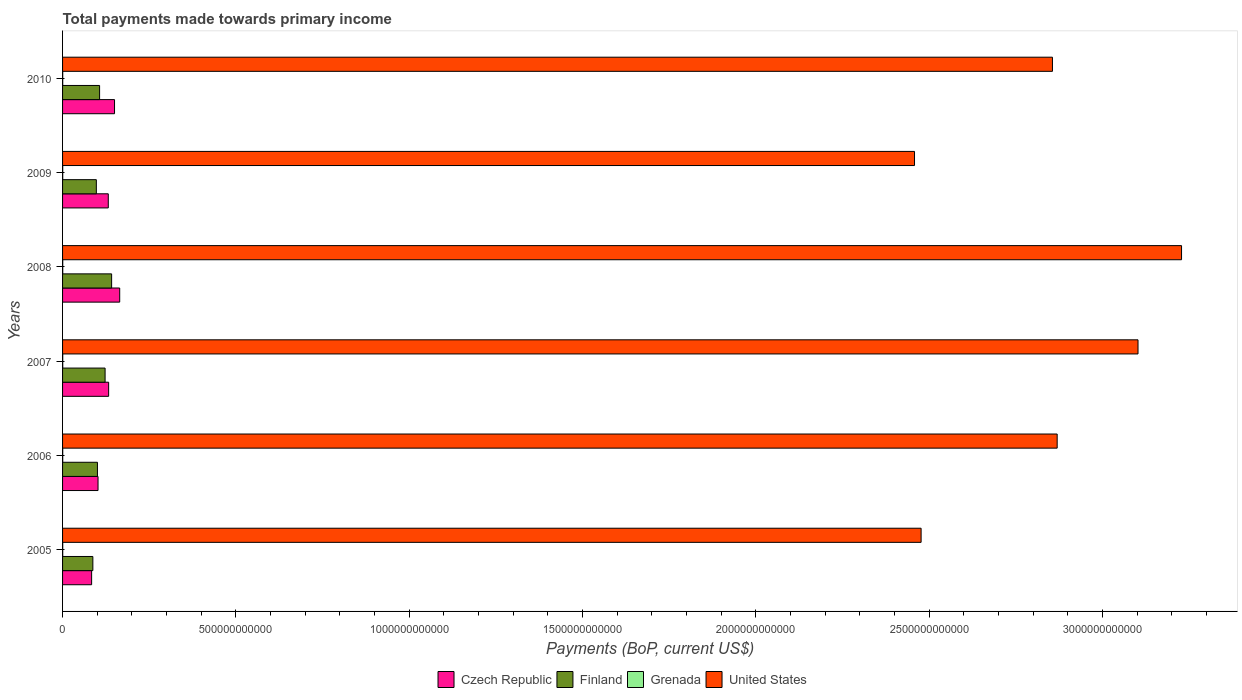How many different coloured bars are there?
Provide a short and direct response. 4. How many groups of bars are there?
Provide a succinct answer. 6. Are the number of bars on each tick of the Y-axis equal?
Your response must be concise. Yes. How many bars are there on the 2nd tick from the bottom?
Provide a short and direct response. 4. In how many cases, is the number of bars for a given year not equal to the number of legend labels?
Offer a very short reply. 0. What is the total payments made towards primary income in United States in 2009?
Give a very brief answer. 2.46e+12. Across all years, what is the maximum total payments made towards primary income in Grenada?
Offer a very short reply. 5.03e+08. Across all years, what is the minimum total payments made towards primary income in United States?
Ensure brevity in your answer.  2.46e+12. What is the total total payments made towards primary income in Czech Republic in the graph?
Your answer should be compact. 7.66e+11. What is the difference between the total payments made towards primary income in Finland in 2007 and that in 2010?
Your response must be concise. 1.58e+1. What is the difference between the total payments made towards primary income in Finland in 2006 and the total payments made towards primary income in Grenada in 2005?
Keep it short and to the point. 1.00e+11. What is the average total payments made towards primary income in United States per year?
Give a very brief answer. 2.83e+12. In the year 2007, what is the difference between the total payments made towards primary income in Finland and total payments made towards primary income in Czech Republic?
Ensure brevity in your answer.  -1.02e+1. What is the ratio of the total payments made towards primary income in Czech Republic in 2009 to that in 2010?
Provide a succinct answer. 0.88. Is the total payments made towards primary income in United States in 2006 less than that in 2007?
Keep it short and to the point. Yes. What is the difference between the highest and the second highest total payments made towards primary income in Finland?
Offer a terse response. 1.89e+1. What is the difference between the highest and the lowest total payments made towards primary income in Grenada?
Your response must be concise. 7.59e+07. In how many years, is the total payments made towards primary income in Czech Republic greater than the average total payments made towards primary income in Czech Republic taken over all years?
Provide a short and direct response. 4. Is it the case that in every year, the sum of the total payments made towards primary income in Czech Republic and total payments made towards primary income in Finland is greater than the sum of total payments made towards primary income in Grenada and total payments made towards primary income in United States?
Offer a very short reply. No. What does the 2nd bar from the top in 2009 represents?
Your response must be concise. Grenada. What does the 4th bar from the bottom in 2008 represents?
Offer a very short reply. United States. Are all the bars in the graph horizontal?
Ensure brevity in your answer.  Yes. How many years are there in the graph?
Give a very brief answer. 6. What is the difference between two consecutive major ticks on the X-axis?
Your response must be concise. 5.00e+11. Are the values on the major ticks of X-axis written in scientific E-notation?
Keep it short and to the point. No. Does the graph contain grids?
Keep it short and to the point. No. How many legend labels are there?
Keep it short and to the point. 4. How are the legend labels stacked?
Provide a succinct answer. Horizontal. What is the title of the graph?
Give a very brief answer. Total payments made towards primary income. What is the label or title of the X-axis?
Provide a short and direct response. Payments (BoP, current US$). What is the label or title of the Y-axis?
Provide a short and direct response. Years. What is the Payments (BoP, current US$) of Czech Republic in 2005?
Your answer should be very brief. 8.38e+1. What is the Payments (BoP, current US$) in Finland in 2005?
Provide a short and direct response. 8.74e+1. What is the Payments (BoP, current US$) in Grenada in 2005?
Make the answer very short. 4.36e+08. What is the Payments (BoP, current US$) of United States in 2005?
Keep it short and to the point. 2.48e+12. What is the Payments (BoP, current US$) in Czech Republic in 2006?
Provide a short and direct response. 1.02e+11. What is the Payments (BoP, current US$) in Finland in 2006?
Offer a terse response. 1.01e+11. What is the Payments (BoP, current US$) of Grenada in 2006?
Offer a very short reply. 4.45e+08. What is the Payments (BoP, current US$) of United States in 2006?
Provide a short and direct response. 2.87e+12. What is the Payments (BoP, current US$) in Czech Republic in 2007?
Your response must be concise. 1.33e+11. What is the Payments (BoP, current US$) in Finland in 2007?
Give a very brief answer. 1.23e+11. What is the Payments (BoP, current US$) in Grenada in 2007?
Make the answer very short. 4.91e+08. What is the Payments (BoP, current US$) in United States in 2007?
Give a very brief answer. 3.10e+12. What is the Payments (BoP, current US$) of Czech Republic in 2008?
Make the answer very short. 1.65e+11. What is the Payments (BoP, current US$) in Finland in 2008?
Offer a very short reply. 1.42e+11. What is the Payments (BoP, current US$) of Grenada in 2008?
Your answer should be compact. 5.03e+08. What is the Payments (BoP, current US$) of United States in 2008?
Give a very brief answer. 3.23e+12. What is the Payments (BoP, current US$) in Czech Republic in 2009?
Give a very brief answer. 1.32e+11. What is the Payments (BoP, current US$) of Finland in 2009?
Provide a succinct answer. 9.74e+1. What is the Payments (BoP, current US$) of Grenada in 2009?
Ensure brevity in your answer.  4.32e+08. What is the Payments (BoP, current US$) in United States in 2009?
Offer a terse response. 2.46e+12. What is the Payments (BoP, current US$) of Czech Republic in 2010?
Keep it short and to the point. 1.50e+11. What is the Payments (BoP, current US$) in Finland in 2010?
Your response must be concise. 1.07e+11. What is the Payments (BoP, current US$) in Grenada in 2010?
Your answer should be compact. 4.27e+08. What is the Payments (BoP, current US$) of United States in 2010?
Offer a terse response. 2.86e+12. Across all years, what is the maximum Payments (BoP, current US$) in Czech Republic?
Offer a very short reply. 1.65e+11. Across all years, what is the maximum Payments (BoP, current US$) of Finland?
Your answer should be compact. 1.42e+11. Across all years, what is the maximum Payments (BoP, current US$) in Grenada?
Your response must be concise. 5.03e+08. Across all years, what is the maximum Payments (BoP, current US$) of United States?
Make the answer very short. 3.23e+12. Across all years, what is the minimum Payments (BoP, current US$) in Czech Republic?
Your answer should be compact. 8.38e+1. Across all years, what is the minimum Payments (BoP, current US$) in Finland?
Provide a succinct answer. 8.74e+1. Across all years, what is the minimum Payments (BoP, current US$) in Grenada?
Your response must be concise. 4.27e+08. Across all years, what is the minimum Payments (BoP, current US$) of United States?
Offer a very short reply. 2.46e+12. What is the total Payments (BoP, current US$) of Czech Republic in the graph?
Your response must be concise. 7.66e+11. What is the total Payments (BoP, current US$) of Finland in the graph?
Provide a short and direct response. 6.56e+11. What is the total Payments (BoP, current US$) of Grenada in the graph?
Offer a very short reply. 2.73e+09. What is the total Payments (BoP, current US$) of United States in the graph?
Make the answer very short. 1.70e+13. What is the difference between the Payments (BoP, current US$) of Czech Republic in 2005 and that in 2006?
Ensure brevity in your answer.  -1.85e+1. What is the difference between the Payments (BoP, current US$) of Finland in 2005 and that in 2006?
Provide a short and direct response. -1.32e+1. What is the difference between the Payments (BoP, current US$) in Grenada in 2005 and that in 2006?
Your response must be concise. -8.66e+06. What is the difference between the Payments (BoP, current US$) of United States in 2005 and that in 2006?
Give a very brief answer. -3.92e+11. What is the difference between the Payments (BoP, current US$) of Czech Republic in 2005 and that in 2007?
Provide a succinct answer. -4.91e+1. What is the difference between the Payments (BoP, current US$) of Finland in 2005 and that in 2007?
Provide a short and direct response. -3.53e+1. What is the difference between the Payments (BoP, current US$) of Grenada in 2005 and that in 2007?
Make the answer very short. -5.53e+07. What is the difference between the Payments (BoP, current US$) in United States in 2005 and that in 2007?
Provide a short and direct response. -6.26e+11. What is the difference between the Payments (BoP, current US$) in Czech Republic in 2005 and that in 2008?
Your response must be concise. -8.10e+1. What is the difference between the Payments (BoP, current US$) of Finland in 2005 and that in 2008?
Your response must be concise. -5.41e+1. What is the difference between the Payments (BoP, current US$) of Grenada in 2005 and that in 2008?
Your response must be concise. -6.67e+07. What is the difference between the Payments (BoP, current US$) of United States in 2005 and that in 2008?
Your response must be concise. -7.51e+11. What is the difference between the Payments (BoP, current US$) in Czech Republic in 2005 and that in 2009?
Your answer should be compact. -4.81e+1. What is the difference between the Payments (BoP, current US$) of Finland in 2005 and that in 2009?
Your response must be concise. -1.01e+1. What is the difference between the Payments (BoP, current US$) in Grenada in 2005 and that in 2009?
Keep it short and to the point. 3.73e+06. What is the difference between the Payments (BoP, current US$) of United States in 2005 and that in 2009?
Offer a very short reply. 1.90e+1. What is the difference between the Payments (BoP, current US$) of Czech Republic in 2005 and that in 2010?
Give a very brief answer. -6.61e+1. What is the difference between the Payments (BoP, current US$) of Finland in 2005 and that in 2010?
Your response must be concise. -1.94e+1. What is the difference between the Payments (BoP, current US$) of Grenada in 2005 and that in 2010?
Offer a terse response. 9.28e+06. What is the difference between the Payments (BoP, current US$) of United States in 2005 and that in 2010?
Provide a succinct answer. -3.79e+11. What is the difference between the Payments (BoP, current US$) in Czech Republic in 2006 and that in 2007?
Give a very brief answer. -3.06e+1. What is the difference between the Payments (BoP, current US$) of Finland in 2006 and that in 2007?
Ensure brevity in your answer.  -2.20e+1. What is the difference between the Payments (BoP, current US$) in Grenada in 2006 and that in 2007?
Keep it short and to the point. -4.66e+07. What is the difference between the Payments (BoP, current US$) in United States in 2006 and that in 2007?
Your answer should be very brief. -2.33e+11. What is the difference between the Payments (BoP, current US$) of Czech Republic in 2006 and that in 2008?
Your answer should be compact. -6.25e+1. What is the difference between the Payments (BoP, current US$) of Finland in 2006 and that in 2008?
Offer a very short reply. -4.09e+1. What is the difference between the Payments (BoP, current US$) of Grenada in 2006 and that in 2008?
Give a very brief answer. -5.80e+07. What is the difference between the Payments (BoP, current US$) in United States in 2006 and that in 2008?
Your answer should be compact. -3.59e+11. What is the difference between the Payments (BoP, current US$) of Czech Republic in 2006 and that in 2009?
Your response must be concise. -2.96e+1. What is the difference between the Payments (BoP, current US$) in Finland in 2006 and that in 2009?
Your answer should be very brief. 3.19e+09. What is the difference between the Payments (BoP, current US$) in Grenada in 2006 and that in 2009?
Give a very brief answer. 1.24e+07. What is the difference between the Payments (BoP, current US$) of United States in 2006 and that in 2009?
Provide a succinct answer. 4.11e+11. What is the difference between the Payments (BoP, current US$) of Czech Republic in 2006 and that in 2010?
Offer a very short reply. -4.76e+1. What is the difference between the Payments (BoP, current US$) of Finland in 2006 and that in 2010?
Make the answer very short. -6.19e+09. What is the difference between the Payments (BoP, current US$) in Grenada in 2006 and that in 2010?
Provide a succinct answer. 1.79e+07. What is the difference between the Payments (BoP, current US$) in United States in 2006 and that in 2010?
Your response must be concise. 1.36e+1. What is the difference between the Payments (BoP, current US$) in Czech Republic in 2007 and that in 2008?
Provide a succinct answer. -3.19e+1. What is the difference between the Payments (BoP, current US$) in Finland in 2007 and that in 2008?
Provide a short and direct response. -1.89e+1. What is the difference between the Payments (BoP, current US$) in Grenada in 2007 and that in 2008?
Your response must be concise. -1.14e+07. What is the difference between the Payments (BoP, current US$) in United States in 2007 and that in 2008?
Provide a succinct answer. -1.26e+11. What is the difference between the Payments (BoP, current US$) of Czech Republic in 2007 and that in 2009?
Your response must be concise. 1.03e+09. What is the difference between the Payments (BoP, current US$) of Finland in 2007 and that in 2009?
Your answer should be very brief. 2.52e+1. What is the difference between the Payments (BoP, current US$) in Grenada in 2007 and that in 2009?
Your response must be concise. 5.90e+07. What is the difference between the Payments (BoP, current US$) of United States in 2007 and that in 2009?
Offer a very short reply. 6.45e+11. What is the difference between the Payments (BoP, current US$) in Czech Republic in 2007 and that in 2010?
Your response must be concise. -1.70e+1. What is the difference between the Payments (BoP, current US$) in Finland in 2007 and that in 2010?
Ensure brevity in your answer.  1.58e+1. What is the difference between the Payments (BoP, current US$) of Grenada in 2007 and that in 2010?
Offer a very short reply. 6.45e+07. What is the difference between the Payments (BoP, current US$) of United States in 2007 and that in 2010?
Offer a very short reply. 2.47e+11. What is the difference between the Payments (BoP, current US$) of Czech Republic in 2008 and that in 2009?
Keep it short and to the point. 3.29e+1. What is the difference between the Payments (BoP, current US$) in Finland in 2008 and that in 2009?
Make the answer very short. 4.41e+1. What is the difference between the Payments (BoP, current US$) of Grenada in 2008 and that in 2009?
Keep it short and to the point. 7.04e+07. What is the difference between the Payments (BoP, current US$) of United States in 2008 and that in 2009?
Your answer should be very brief. 7.70e+11. What is the difference between the Payments (BoP, current US$) of Czech Republic in 2008 and that in 2010?
Provide a succinct answer. 1.49e+1. What is the difference between the Payments (BoP, current US$) of Finland in 2008 and that in 2010?
Make the answer very short. 3.47e+1. What is the difference between the Payments (BoP, current US$) of Grenada in 2008 and that in 2010?
Provide a succinct answer. 7.59e+07. What is the difference between the Payments (BoP, current US$) of United States in 2008 and that in 2010?
Offer a very short reply. 3.72e+11. What is the difference between the Payments (BoP, current US$) in Czech Republic in 2009 and that in 2010?
Give a very brief answer. -1.80e+1. What is the difference between the Payments (BoP, current US$) in Finland in 2009 and that in 2010?
Your response must be concise. -9.38e+09. What is the difference between the Payments (BoP, current US$) in Grenada in 2009 and that in 2010?
Offer a very short reply. 5.55e+06. What is the difference between the Payments (BoP, current US$) of United States in 2009 and that in 2010?
Your answer should be compact. -3.98e+11. What is the difference between the Payments (BoP, current US$) of Czech Republic in 2005 and the Payments (BoP, current US$) of Finland in 2006?
Offer a very short reply. -1.68e+1. What is the difference between the Payments (BoP, current US$) of Czech Republic in 2005 and the Payments (BoP, current US$) of Grenada in 2006?
Give a very brief answer. 8.34e+1. What is the difference between the Payments (BoP, current US$) in Czech Republic in 2005 and the Payments (BoP, current US$) in United States in 2006?
Make the answer very short. -2.79e+12. What is the difference between the Payments (BoP, current US$) in Finland in 2005 and the Payments (BoP, current US$) in Grenada in 2006?
Keep it short and to the point. 8.69e+1. What is the difference between the Payments (BoP, current US$) of Finland in 2005 and the Payments (BoP, current US$) of United States in 2006?
Offer a very short reply. -2.78e+12. What is the difference between the Payments (BoP, current US$) in Grenada in 2005 and the Payments (BoP, current US$) in United States in 2006?
Offer a terse response. -2.87e+12. What is the difference between the Payments (BoP, current US$) of Czech Republic in 2005 and the Payments (BoP, current US$) of Finland in 2007?
Give a very brief answer. -3.89e+1. What is the difference between the Payments (BoP, current US$) in Czech Republic in 2005 and the Payments (BoP, current US$) in Grenada in 2007?
Offer a very short reply. 8.33e+1. What is the difference between the Payments (BoP, current US$) in Czech Republic in 2005 and the Payments (BoP, current US$) in United States in 2007?
Offer a terse response. -3.02e+12. What is the difference between the Payments (BoP, current US$) in Finland in 2005 and the Payments (BoP, current US$) in Grenada in 2007?
Ensure brevity in your answer.  8.69e+1. What is the difference between the Payments (BoP, current US$) in Finland in 2005 and the Payments (BoP, current US$) in United States in 2007?
Your answer should be compact. -3.01e+12. What is the difference between the Payments (BoP, current US$) of Grenada in 2005 and the Payments (BoP, current US$) of United States in 2007?
Make the answer very short. -3.10e+12. What is the difference between the Payments (BoP, current US$) in Czech Republic in 2005 and the Payments (BoP, current US$) in Finland in 2008?
Your answer should be compact. -5.77e+1. What is the difference between the Payments (BoP, current US$) in Czech Republic in 2005 and the Payments (BoP, current US$) in Grenada in 2008?
Provide a short and direct response. 8.33e+1. What is the difference between the Payments (BoP, current US$) in Czech Republic in 2005 and the Payments (BoP, current US$) in United States in 2008?
Your answer should be compact. -3.14e+12. What is the difference between the Payments (BoP, current US$) in Finland in 2005 and the Payments (BoP, current US$) in Grenada in 2008?
Offer a terse response. 8.69e+1. What is the difference between the Payments (BoP, current US$) in Finland in 2005 and the Payments (BoP, current US$) in United States in 2008?
Make the answer very short. -3.14e+12. What is the difference between the Payments (BoP, current US$) in Grenada in 2005 and the Payments (BoP, current US$) in United States in 2008?
Your answer should be compact. -3.23e+12. What is the difference between the Payments (BoP, current US$) in Czech Republic in 2005 and the Payments (BoP, current US$) in Finland in 2009?
Offer a very short reply. -1.36e+1. What is the difference between the Payments (BoP, current US$) in Czech Republic in 2005 and the Payments (BoP, current US$) in Grenada in 2009?
Provide a short and direct response. 8.34e+1. What is the difference between the Payments (BoP, current US$) in Czech Republic in 2005 and the Payments (BoP, current US$) in United States in 2009?
Provide a short and direct response. -2.37e+12. What is the difference between the Payments (BoP, current US$) in Finland in 2005 and the Payments (BoP, current US$) in Grenada in 2009?
Your response must be concise. 8.70e+1. What is the difference between the Payments (BoP, current US$) in Finland in 2005 and the Payments (BoP, current US$) in United States in 2009?
Provide a short and direct response. -2.37e+12. What is the difference between the Payments (BoP, current US$) in Grenada in 2005 and the Payments (BoP, current US$) in United States in 2009?
Keep it short and to the point. -2.46e+12. What is the difference between the Payments (BoP, current US$) in Czech Republic in 2005 and the Payments (BoP, current US$) in Finland in 2010?
Provide a short and direct response. -2.30e+1. What is the difference between the Payments (BoP, current US$) in Czech Republic in 2005 and the Payments (BoP, current US$) in Grenada in 2010?
Your answer should be very brief. 8.34e+1. What is the difference between the Payments (BoP, current US$) of Czech Republic in 2005 and the Payments (BoP, current US$) of United States in 2010?
Offer a terse response. -2.77e+12. What is the difference between the Payments (BoP, current US$) in Finland in 2005 and the Payments (BoP, current US$) in Grenada in 2010?
Your response must be concise. 8.70e+1. What is the difference between the Payments (BoP, current US$) in Finland in 2005 and the Payments (BoP, current US$) in United States in 2010?
Ensure brevity in your answer.  -2.77e+12. What is the difference between the Payments (BoP, current US$) of Grenada in 2005 and the Payments (BoP, current US$) of United States in 2010?
Your response must be concise. -2.86e+12. What is the difference between the Payments (BoP, current US$) of Czech Republic in 2006 and the Payments (BoP, current US$) of Finland in 2007?
Offer a very short reply. -2.04e+1. What is the difference between the Payments (BoP, current US$) in Czech Republic in 2006 and the Payments (BoP, current US$) in Grenada in 2007?
Make the answer very short. 1.02e+11. What is the difference between the Payments (BoP, current US$) in Czech Republic in 2006 and the Payments (BoP, current US$) in United States in 2007?
Keep it short and to the point. -3.00e+12. What is the difference between the Payments (BoP, current US$) in Finland in 2006 and the Payments (BoP, current US$) in Grenada in 2007?
Offer a terse response. 1.00e+11. What is the difference between the Payments (BoP, current US$) in Finland in 2006 and the Payments (BoP, current US$) in United States in 2007?
Ensure brevity in your answer.  -3.00e+12. What is the difference between the Payments (BoP, current US$) of Grenada in 2006 and the Payments (BoP, current US$) of United States in 2007?
Give a very brief answer. -3.10e+12. What is the difference between the Payments (BoP, current US$) of Czech Republic in 2006 and the Payments (BoP, current US$) of Finland in 2008?
Give a very brief answer. -3.92e+1. What is the difference between the Payments (BoP, current US$) in Czech Republic in 2006 and the Payments (BoP, current US$) in Grenada in 2008?
Offer a very short reply. 1.02e+11. What is the difference between the Payments (BoP, current US$) of Czech Republic in 2006 and the Payments (BoP, current US$) of United States in 2008?
Your answer should be very brief. -3.13e+12. What is the difference between the Payments (BoP, current US$) in Finland in 2006 and the Payments (BoP, current US$) in Grenada in 2008?
Your response must be concise. 1.00e+11. What is the difference between the Payments (BoP, current US$) in Finland in 2006 and the Payments (BoP, current US$) in United States in 2008?
Ensure brevity in your answer.  -3.13e+12. What is the difference between the Payments (BoP, current US$) of Grenada in 2006 and the Payments (BoP, current US$) of United States in 2008?
Your answer should be compact. -3.23e+12. What is the difference between the Payments (BoP, current US$) in Czech Republic in 2006 and the Payments (BoP, current US$) in Finland in 2009?
Provide a succinct answer. 4.87e+09. What is the difference between the Payments (BoP, current US$) of Czech Republic in 2006 and the Payments (BoP, current US$) of Grenada in 2009?
Provide a succinct answer. 1.02e+11. What is the difference between the Payments (BoP, current US$) of Czech Republic in 2006 and the Payments (BoP, current US$) of United States in 2009?
Your response must be concise. -2.36e+12. What is the difference between the Payments (BoP, current US$) of Finland in 2006 and the Payments (BoP, current US$) of Grenada in 2009?
Provide a short and direct response. 1.00e+11. What is the difference between the Payments (BoP, current US$) in Finland in 2006 and the Payments (BoP, current US$) in United States in 2009?
Provide a short and direct response. -2.36e+12. What is the difference between the Payments (BoP, current US$) in Grenada in 2006 and the Payments (BoP, current US$) in United States in 2009?
Your answer should be compact. -2.46e+12. What is the difference between the Payments (BoP, current US$) of Czech Republic in 2006 and the Payments (BoP, current US$) of Finland in 2010?
Your answer should be compact. -4.51e+09. What is the difference between the Payments (BoP, current US$) of Czech Republic in 2006 and the Payments (BoP, current US$) of Grenada in 2010?
Give a very brief answer. 1.02e+11. What is the difference between the Payments (BoP, current US$) of Czech Republic in 2006 and the Payments (BoP, current US$) of United States in 2010?
Your response must be concise. -2.75e+12. What is the difference between the Payments (BoP, current US$) of Finland in 2006 and the Payments (BoP, current US$) of Grenada in 2010?
Your answer should be compact. 1.00e+11. What is the difference between the Payments (BoP, current US$) in Finland in 2006 and the Payments (BoP, current US$) in United States in 2010?
Your response must be concise. -2.75e+12. What is the difference between the Payments (BoP, current US$) of Grenada in 2006 and the Payments (BoP, current US$) of United States in 2010?
Offer a very short reply. -2.86e+12. What is the difference between the Payments (BoP, current US$) of Czech Republic in 2007 and the Payments (BoP, current US$) of Finland in 2008?
Provide a short and direct response. -8.60e+09. What is the difference between the Payments (BoP, current US$) in Czech Republic in 2007 and the Payments (BoP, current US$) in Grenada in 2008?
Offer a terse response. 1.32e+11. What is the difference between the Payments (BoP, current US$) of Czech Republic in 2007 and the Payments (BoP, current US$) of United States in 2008?
Give a very brief answer. -3.09e+12. What is the difference between the Payments (BoP, current US$) in Finland in 2007 and the Payments (BoP, current US$) in Grenada in 2008?
Offer a very short reply. 1.22e+11. What is the difference between the Payments (BoP, current US$) in Finland in 2007 and the Payments (BoP, current US$) in United States in 2008?
Provide a succinct answer. -3.11e+12. What is the difference between the Payments (BoP, current US$) of Grenada in 2007 and the Payments (BoP, current US$) of United States in 2008?
Give a very brief answer. -3.23e+12. What is the difference between the Payments (BoP, current US$) in Czech Republic in 2007 and the Payments (BoP, current US$) in Finland in 2009?
Offer a very short reply. 3.55e+1. What is the difference between the Payments (BoP, current US$) of Czech Republic in 2007 and the Payments (BoP, current US$) of Grenada in 2009?
Provide a short and direct response. 1.32e+11. What is the difference between the Payments (BoP, current US$) of Czech Republic in 2007 and the Payments (BoP, current US$) of United States in 2009?
Offer a terse response. -2.32e+12. What is the difference between the Payments (BoP, current US$) of Finland in 2007 and the Payments (BoP, current US$) of Grenada in 2009?
Your answer should be compact. 1.22e+11. What is the difference between the Payments (BoP, current US$) in Finland in 2007 and the Payments (BoP, current US$) in United States in 2009?
Make the answer very short. -2.33e+12. What is the difference between the Payments (BoP, current US$) in Grenada in 2007 and the Payments (BoP, current US$) in United States in 2009?
Provide a short and direct response. -2.46e+12. What is the difference between the Payments (BoP, current US$) in Czech Republic in 2007 and the Payments (BoP, current US$) in Finland in 2010?
Your answer should be compact. 2.61e+1. What is the difference between the Payments (BoP, current US$) in Czech Republic in 2007 and the Payments (BoP, current US$) in Grenada in 2010?
Ensure brevity in your answer.  1.32e+11. What is the difference between the Payments (BoP, current US$) of Czech Republic in 2007 and the Payments (BoP, current US$) of United States in 2010?
Offer a very short reply. -2.72e+12. What is the difference between the Payments (BoP, current US$) in Finland in 2007 and the Payments (BoP, current US$) in Grenada in 2010?
Your answer should be compact. 1.22e+11. What is the difference between the Payments (BoP, current US$) of Finland in 2007 and the Payments (BoP, current US$) of United States in 2010?
Your answer should be compact. -2.73e+12. What is the difference between the Payments (BoP, current US$) in Grenada in 2007 and the Payments (BoP, current US$) in United States in 2010?
Provide a short and direct response. -2.86e+12. What is the difference between the Payments (BoP, current US$) of Czech Republic in 2008 and the Payments (BoP, current US$) of Finland in 2009?
Keep it short and to the point. 6.74e+1. What is the difference between the Payments (BoP, current US$) of Czech Republic in 2008 and the Payments (BoP, current US$) of Grenada in 2009?
Give a very brief answer. 1.64e+11. What is the difference between the Payments (BoP, current US$) of Czech Republic in 2008 and the Payments (BoP, current US$) of United States in 2009?
Ensure brevity in your answer.  -2.29e+12. What is the difference between the Payments (BoP, current US$) in Finland in 2008 and the Payments (BoP, current US$) in Grenada in 2009?
Your answer should be very brief. 1.41e+11. What is the difference between the Payments (BoP, current US$) of Finland in 2008 and the Payments (BoP, current US$) of United States in 2009?
Ensure brevity in your answer.  -2.32e+12. What is the difference between the Payments (BoP, current US$) in Grenada in 2008 and the Payments (BoP, current US$) in United States in 2009?
Provide a short and direct response. -2.46e+12. What is the difference between the Payments (BoP, current US$) in Czech Republic in 2008 and the Payments (BoP, current US$) in Finland in 2010?
Offer a very short reply. 5.80e+1. What is the difference between the Payments (BoP, current US$) in Czech Republic in 2008 and the Payments (BoP, current US$) in Grenada in 2010?
Provide a succinct answer. 1.64e+11. What is the difference between the Payments (BoP, current US$) of Czech Republic in 2008 and the Payments (BoP, current US$) of United States in 2010?
Offer a very short reply. -2.69e+12. What is the difference between the Payments (BoP, current US$) in Finland in 2008 and the Payments (BoP, current US$) in Grenada in 2010?
Offer a very short reply. 1.41e+11. What is the difference between the Payments (BoP, current US$) of Finland in 2008 and the Payments (BoP, current US$) of United States in 2010?
Your answer should be very brief. -2.71e+12. What is the difference between the Payments (BoP, current US$) of Grenada in 2008 and the Payments (BoP, current US$) of United States in 2010?
Provide a succinct answer. -2.86e+12. What is the difference between the Payments (BoP, current US$) of Czech Republic in 2009 and the Payments (BoP, current US$) of Finland in 2010?
Provide a succinct answer. 2.51e+1. What is the difference between the Payments (BoP, current US$) in Czech Republic in 2009 and the Payments (BoP, current US$) in Grenada in 2010?
Give a very brief answer. 1.31e+11. What is the difference between the Payments (BoP, current US$) of Czech Republic in 2009 and the Payments (BoP, current US$) of United States in 2010?
Your response must be concise. -2.72e+12. What is the difference between the Payments (BoP, current US$) of Finland in 2009 and the Payments (BoP, current US$) of Grenada in 2010?
Provide a succinct answer. 9.70e+1. What is the difference between the Payments (BoP, current US$) in Finland in 2009 and the Payments (BoP, current US$) in United States in 2010?
Your response must be concise. -2.76e+12. What is the difference between the Payments (BoP, current US$) in Grenada in 2009 and the Payments (BoP, current US$) in United States in 2010?
Keep it short and to the point. -2.86e+12. What is the average Payments (BoP, current US$) of Czech Republic per year?
Provide a short and direct response. 1.28e+11. What is the average Payments (BoP, current US$) of Finland per year?
Offer a terse response. 1.09e+11. What is the average Payments (BoP, current US$) of Grenada per year?
Your answer should be very brief. 4.55e+08. What is the average Payments (BoP, current US$) of United States per year?
Make the answer very short. 2.83e+12. In the year 2005, what is the difference between the Payments (BoP, current US$) in Czech Republic and Payments (BoP, current US$) in Finland?
Offer a very short reply. -3.58e+09. In the year 2005, what is the difference between the Payments (BoP, current US$) in Czech Republic and Payments (BoP, current US$) in Grenada?
Offer a terse response. 8.34e+1. In the year 2005, what is the difference between the Payments (BoP, current US$) of Czech Republic and Payments (BoP, current US$) of United States?
Keep it short and to the point. -2.39e+12. In the year 2005, what is the difference between the Payments (BoP, current US$) in Finland and Payments (BoP, current US$) in Grenada?
Provide a succinct answer. 8.70e+1. In the year 2005, what is the difference between the Payments (BoP, current US$) of Finland and Payments (BoP, current US$) of United States?
Make the answer very short. -2.39e+12. In the year 2005, what is the difference between the Payments (BoP, current US$) of Grenada and Payments (BoP, current US$) of United States?
Provide a short and direct response. -2.48e+12. In the year 2006, what is the difference between the Payments (BoP, current US$) in Czech Republic and Payments (BoP, current US$) in Finland?
Offer a terse response. 1.69e+09. In the year 2006, what is the difference between the Payments (BoP, current US$) of Czech Republic and Payments (BoP, current US$) of Grenada?
Keep it short and to the point. 1.02e+11. In the year 2006, what is the difference between the Payments (BoP, current US$) of Czech Republic and Payments (BoP, current US$) of United States?
Your answer should be very brief. -2.77e+12. In the year 2006, what is the difference between the Payments (BoP, current US$) in Finland and Payments (BoP, current US$) in Grenada?
Offer a terse response. 1.00e+11. In the year 2006, what is the difference between the Payments (BoP, current US$) of Finland and Payments (BoP, current US$) of United States?
Your response must be concise. -2.77e+12. In the year 2006, what is the difference between the Payments (BoP, current US$) in Grenada and Payments (BoP, current US$) in United States?
Your response must be concise. -2.87e+12. In the year 2007, what is the difference between the Payments (BoP, current US$) in Czech Republic and Payments (BoP, current US$) in Finland?
Provide a succinct answer. 1.02e+1. In the year 2007, what is the difference between the Payments (BoP, current US$) of Czech Republic and Payments (BoP, current US$) of Grenada?
Your answer should be very brief. 1.32e+11. In the year 2007, what is the difference between the Payments (BoP, current US$) of Czech Republic and Payments (BoP, current US$) of United States?
Offer a terse response. -2.97e+12. In the year 2007, what is the difference between the Payments (BoP, current US$) of Finland and Payments (BoP, current US$) of Grenada?
Give a very brief answer. 1.22e+11. In the year 2007, what is the difference between the Payments (BoP, current US$) of Finland and Payments (BoP, current US$) of United States?
Your answer should be compact. -2.98e+12. In the year 2007, what is the difference between the Payments (BoP, current US$) in Grenada and Payments (BoP, current US$) in United States?
Your response must be concise. -3.10e+12. In the year 2008, what is the difference between the Payments (BoP, current US$) of Czech Republic and Payments (BoP, current US$) of Finland?
Keep it short and to the point. 2.33e+1. In the year 2008, what is the difference between the Payments (BoP, current US$) in Czech Republic and Payments (BoP, current US$) in Grenada?
Provide a short and direct response. 1.64e+11. In the year 2008, what is the difference between the Payments (BoP, current US$) of Czech Republic and Payments (BoP, current US$) of United States?
Your answer should be compact. -3.06e+12. In the year 2008, what is the difference between the Payments (BoP, current US$) in Finland and Payments (BoP, current US$) in Grenada?
Your response must be concise. 1.41e+11. In the year 2008, what is the difference between the Payments (BoP, current US$) of Finland and Payments (BoP, current US$) of United States?
Your response must be concise. -3.09e+12. In the year 2008, what is the difference between the Payments (BoP, current US$) of Grenada and Payments (BoP, current US$) of United States?
Your response must be concise. -3.23e+12. In the year 2009, what is the difference between the Payments (BoP, current US$) in Czech Republic and Payments (BoP, current US$) in Finland?
Offer a terse response. 3.44e+1. In the year 2009, what is the difference between the Payments (BoP, current US$) of Czech Republic and Payments (BoP, current US$) of Grenada?
Your answer should be very brief. 1.31e+11. In the year 2009, what is the difference between the Payments (BoP, current US$) of Czech Republic and Payments (BoP, current US$) of United States?
Make the answer very short. -2.33e+12. In the year 2009, what is the difference between the Payments (BoP, current US$) in Finland and Payments (BoP, current US$) in Grenada?
Offer a very short reply. 9.70e+1. In the year 2009, what is the difference between the Payments (BoP, current US$) of Finland and Payments (BoP, current US$) of United States?
Make the answer very short. -2.36e+12. In the year 2009, what is the difference between the Payments (BoP, current US$) in Grenada and Payments (BoP, current US$) in United States?
Make the answer very short. -2.46e+12. In the year 2010, what is the difference between the Payments (BoP, current US$) of Czech Republic and Payments (BoP, current US$) of Finland?
Give a very brief answer. 4.31e+1. In the year 2010, what is the difference between the Payments (BoP, current US$) in Czech Republic and Payments (BoP, current US$) in Grenada?
Provide a succinct answer. 1.49e+11. In the year 2010, what is the difference between the Payments (BoP, current US$) in Czech Republic and Payments (BoP, current US$) in United States?
Your answer should be compact. -2.71e+12. In the year 2010, what is the difference between the Payments (BoP, current US$) of Finland and Payments (BoP, current US$) of Grenada?
Your answer should be compact. 1.06e+11. In the year 2010, what is the difference between the Payments (BoP, current US$) of Finland and Payments (BoP, current US$) of United States?
Your answer should be compact. -2.75e+12. In the year 2010, what is the difference between the Payments (BoP, current US$) of Grenada and Payments (BoP, current US$) of United States?
Keep it short and to the point. -2.86e+12. What is the ratio of the Payments (BoP, current US$) of Czech Republic in 2005 to that in 2006?
Give a very brief answer. 0.82. What is the ratio of the Payments (BoP, current US$) in Finland in 2005 to that in 2006?
Make the answer very short. 0.87. What is the ratio of the Payments (BoP, current US$) in Grenada in 2005 to that in 2006?
Give a very brief answer. 0.98. What is the ratio of the Payments (BoP, current US$) in United States in 2005 to that in 2006?
Your answer should be very brief. 0.86. What is the ratio of the Payments (BoP, current US$) of Czech Republic in 2005 to that in 2007?
Your response must be concise. 0.63. What is the ratio of the Payments (BoP, current US$) in Finland in 2005 to that in 2007?
Offer a terse response. 0.71. What is the ratio of the Payments (BoP, current US$) of Grenada in 2005 to that in 2007?
Keep it short and to the point. 0.89. What is the ratio of the Payments (BoP, current US$) of United States in 2005 to that in 2007?
Offer a terse response. 0.8. What is the ratio of the Payments (BoP, current US$) of Czech Republic in 2005 to that in 2008?
Keep it short and to the point. 0.51. What is the ratio of the Payments (BoP, current US$) of Finland in 2005 to that in 2008?
Your answer should be compact. 0.62. What is the ratio of the Payments (BoP, current US$) of Grenada in 2005 to that in 2008?
Offer a very short reply. 0.87. What is the ratio of the Payments (BoP, current US$) of United States in 2005 to that in 2008?
Offer a very short reply. 0.77. What is the ratio of the Payments (BoP, current US$) of Czech Republic in 2005 to that in 2009?
Ensure brevity in your answer.  0.64. What is the ratio of the Payments (BoP, current US$) in Finland in 2005 to that in 2009?
Your answer should be very brief. 0.9. What is the ratio of the Payments (BoP, current US$) of Grenada in 2005 to that in 2009?
Your answer should be very brief. 1.01. What is the ratio of the Payments (BoP, current US$) of United States in 2005 to that in 2009?
Your answer should be compact. 1.01. What is the ratio of the Payments (BoP, current US$) in Czech Republic in 2005 to that in 2010?
Offer a very short reply. 0.56. What is the ratio of the Payments (BoP, current US$) of Finland in 2005 to that in 2010?
Provide a short and direct response. 0.82. What is the ratio of the Payments (BoP, current US$) in Grenada in 2005 to that in 2010?
Keep it short and to the point. 1.02. What is the ratio of the Payments (BoP, current US$) of United States in 2005 to that in 2010?
Give a very brief answer. 0.87. What is the ratio of the Payments (BoP, current US$) of Czech Republic in 2006 to that in 2007?
Provide a short and direct response. 0.77. What is the ratio of the Payments (BoP, current US$) in Finland in 2006 to that in 2007?
Provide a succinct answer. 0.82. What is the ratio of the Payments (BoP, current US$) in Grenada in 2006 to that in 2007?
Offer a very short reply. 0.91. What is the ratio of the Payments (BoP, current US$) in United States in 2006 to that in 2007?
Your response must be concise. 0.92. What is the ratio of the Payments (BoP, current US$) of Czech Republic in 2006 to that in 2008?
Provide a succinct answer. 0.62. What is the ratio of the Payments (BoP, current US$) of Finland in 2006 to that in 2008?
Offer a very short reply. 0.71. What is the ratio of the Payments (BoP, current US$) in Grenada in 2006 to that in 2008?
Your response must be concise. 0.88. What is the ratio of the Payments (BoP, current US$) in United States in 2006 to that in 2008?
Ensure brevity in your answer.  0.89. What is the ratio of the Payments (BoP, current US$) in Czech Republic in 2006 to that in 2009?
Offer a very short reply. 0.78. What is the ratio of the Payments (BoP, current US$) in Finland in 2006 to that in 2009?
Ensure brevity in your answer.  1.03. What is the ratio of the Payments (BoP, current US$) in Grenada in 2006 to that in 2009?
Keep it short and to the point. 1.03. What is the ratio of the Payments (BoP, current US$) of United States in 2006 to that in 2009?
Ensure brevity in your answer.  1.17. What is the ratio of the Payments (BoP, current US$) of Czech Republic in 2006 to that in 2010?
Your answer should be very brief. 0.68. What is the ratio of the Payments (BoP, current US$) in Finland in 2006 to that in 2010?
Your response must be concise. 0.94. What is the ratio of the Payments (BoP, current US$) in Grenada in 2006 to that in 2010?
Make the answer very short. 1.04. What is the ratio of the Payments (BoP, current US$) of Czech Republic in 2007 to that in 2008?
Offer a very short reply. 0.81. What is the ratio of the Payments (BoP, current US$) in Finland in 2007 to that in 2008?
Your answer should be compact. 0.87. What is the ratio of the Payments (BoP, current US$) of Grenada in 2007 to that in 2008?
Offer a terse response. 0.98. What is the ratio of the Payments (BoP, current US$) of United States in 2007 to that in 2008?
Provide a short and direct response. 0.96. What is the ratio of the Payments (BoP, current US$) in Finland in 2007 to that in 2009?
Keep it short and to the point. 1.26. What is the ratio of the Payments (BoP, current US$) of Grenada in 2007 to that in 2009?
Keep it short and to the point. 1.14. What is the ratio of the Payments (BoP, current US$) of United States in 2007 to that in 2009?
Give a very brief answer. 1.26. What is the ratio of the Payments (BoP, current US$) of Czech Republic in 2007 to that in 2010?
Offer a terse response. 0.89. What is the ratio of the Payments (BoP, current US$) of Finland in 2007 to that in 2010?
Your answer should be very brief. 1.15. What is the ratio of the Payments (BoP, current US$) in Grenada in 2007 to that in 2010?
Your answer should be compact. 1.15. What is the ratio of the Payments (BoP, current US$) in United States in 2007 to that in 2010?
Provide a succinct answer. 1.09. What is the ratio of the Payments (BoP, current US$) in Czech Republic in 2008 to that in 2009?
Provide a succinct answer. 1.25. What is the ratio of the Payments (BoP, current US$) in Finland in 2008 to that in 2009?
Make the answer very short. 1.45. What is the ratio of the Payments (BoP, current US$) of Grenada in 2008 to that in 2009?
Make the answer very short. 1.16. What is the ratio of the Payments (BoP, current US$) in United States in 2008 to that in 2009?
Your response must be concise. 1.31. What is the ratio of the Payments (BoP, current US$) in Czech Republic in 2008 to that in 2010?
Your answer should be very brief. 1.1. What is the ratio of the Payments (BoP, current US$) in Finland in 2008 to that in 2010?
Provide a short and direct response. 1.32. What is the ratio of the Payments (BoP, current US$) in Grenada in 2008 to that in 2010?
Keep it short and to the point. 1.18. What is the ratio of the Payments (BoP, current US$) of United States in 2008 to that in 2010?
Your response must be concise. 1.13. What is the ratio of the Payments (BoP, current US$) of Czech Republic in 2009 to that in 2010?
Provide a short and direct response. 0.88. What is the ratio of the Payments (BoP, current US$) in Finland in 2009 to that in 2010?
Ensure brevity in your answer.  0.91. What is the ratio of the Payments (BoP, current US$) of United States in 2009 to that in 2010?
Keep it short and to the point. 0.86. What is the difference between the highest and the second highest Payments (BoP, current US$) of Czech Republic?
Provide a succinct answer. 1.49e+1. What is the difference between the highest and the second highest Payments (BoP, current US$) of Finland?
Your response must be concise. 1.89e+1. What is the difference between the highest and the second highest Payments (BoP, current US$) of Grenada?
Keep it short and to the point. 1.14e+07. What is the difference between the highest and the second highest Payments (BoP, current US$) in United States?
Provide a short and direct response. 1.26e+11. What is the difference between the highest and the lowest Payments (BoP, current US$) in Czech Republic?
Your answer should be compact. 8.10e+1. What is the difference between the highest and the lowest Payments (BoP, current US$) in Finland?
Provide a succinct answer. 5.41e+1. What is the difference between the highest and the lowest Payments (BoP, current US$) in Grenada?
Your answer should be compact. 7.59e+07. What is the difference between the highest and the lowest Payments (BoP, current US$) in United States?
Your response must be concise. 7.70e+11. 